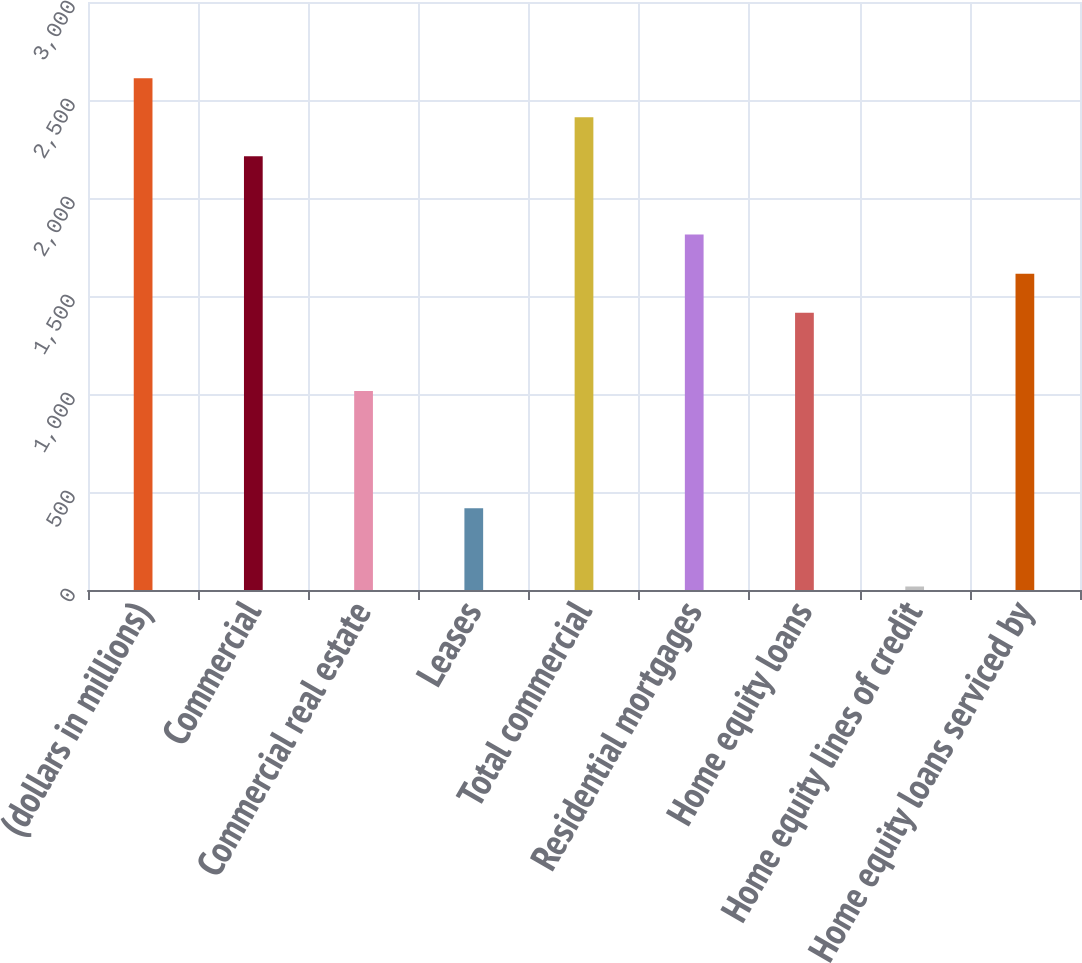<chart> <loc_0><loc_0><loc_500><loc_500><bar_chart><fcel>(dollars in millions)<fcel>Commercial<fcel>Commercial real estate<fcel>Leases<fcel>Total commercial<fcel>Residential mortgages<fcel>Home equity loans<fcel>Home equity lines of credit<fcel>Home equity loans serviced by<nl><fcel>2611.5<fcel>2212.5<fcel>1015.5<fcel>417<fcel>2412<fcel>1813.5<fcel>1414.5<fcel>18<fcel>1614<nl></chart> 